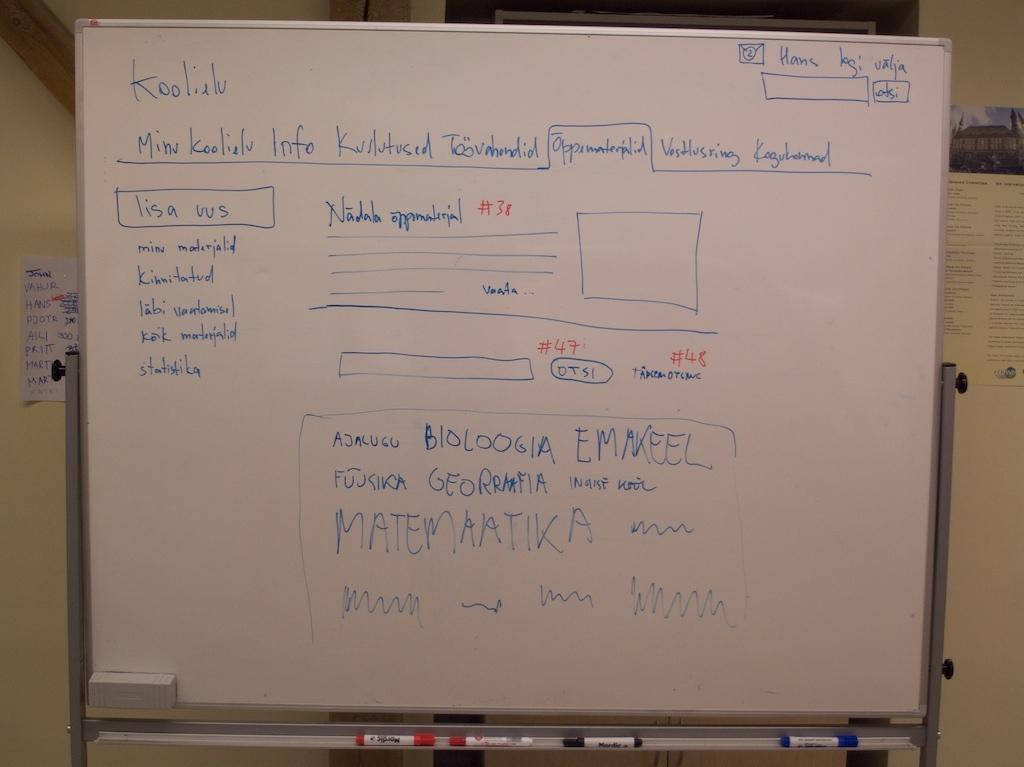Provide a one-sentence caption for the provided image. A whiteboard is used to sketch a website design for a page called Koolielu. 